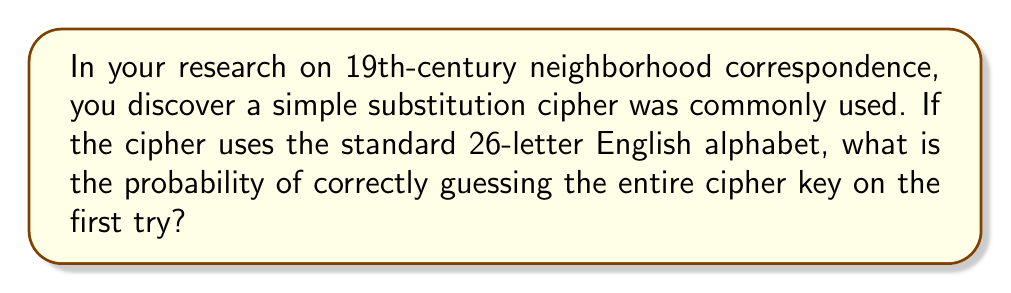Can you answer this question? To solve this problem, we need to consider the following steps:

1. In a simple substitution cipher, each letter of the alphabet is replaced by another letter, creating a one-to-one mapping.

2. For the first letter, we have 26 choices.

3. For the second letter, we have 25 choices, as one letter has already been used.

4. This pattern continues, with each subsequent letter having one fewer choice.

5. The total number of possible arrangements is therefore:

   $$26 \times 25 \times 24 \times ... \times 2 \times 1 = 26!$$

6. The probability of guessing the correct arrangement on the first try is:

   $$P(\text{correct guess}) = \frac{1}{\text{total number of possible arrangements}}$$

   $$P(\text{correct guess}) = \frac{1}{26!}$$

7. Calculate the value of 26!:
   
   $$26! = 4.0329 \times 10^{26}$$

8. Therefore, the probability is:

   $$P(\text{correct guess}) = \frac{1}{4.0329 \times 10^{26}} \approx 2.4796 \times 10^{-27}$$
Answer: $2.4796 \times 10^{-27}$ 